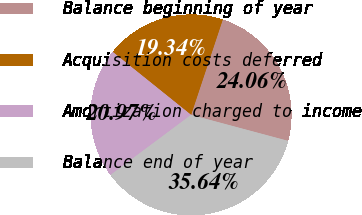Convert chart to OTSL. <chart><loc_0><loc_0><loc_500><loc_500><pie_chart><fcel>Balance beginning of year<fcel>Acquisition costs deferred<fcel>Amortization charged to income<fcel>Balance end of year<nl><fcel>24.06%<fcel>19.34%<fcel>20.97%<fcel>35.64%<nl></chart> 